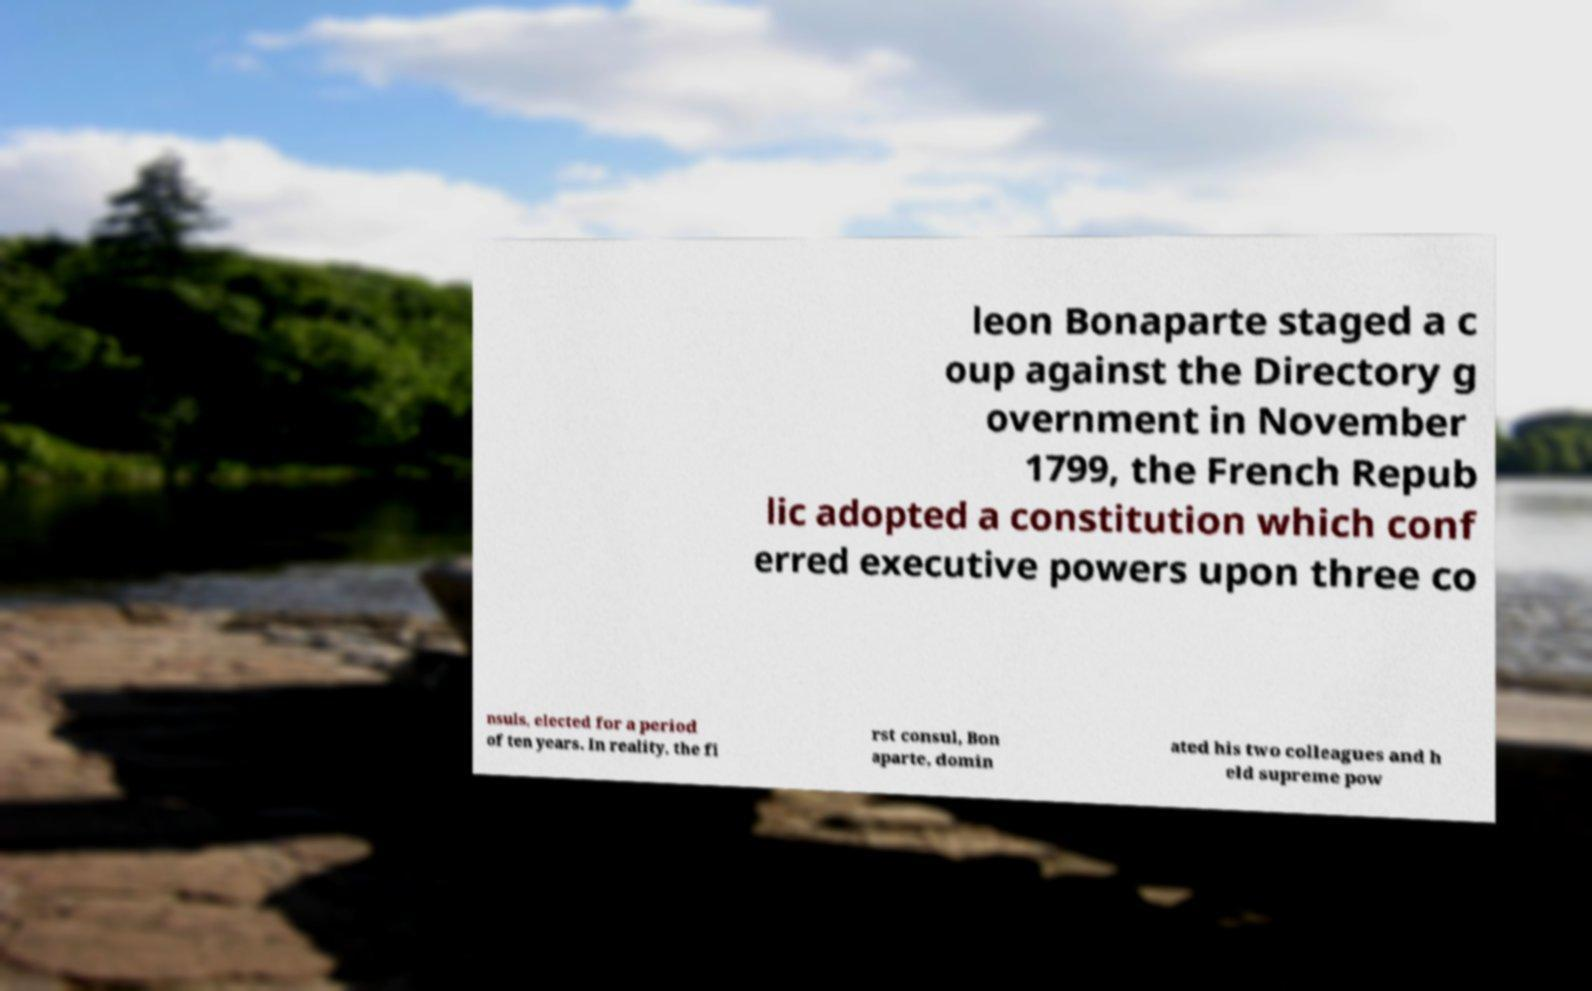Can you read and provide the text displayed in the image?This photo seems to have some interesting text. Can you extract and type it out for me? leon Bonaparte staged a c oup against the Directory g overnment in November 1799, the French Repub lic adopted a constitution which conf erred executive powers upon three co nsuls, elected for a period of ten years. In reality, the fi rst consul, Bon aparte, domin ated his two colleagues and h eld supreme pow 